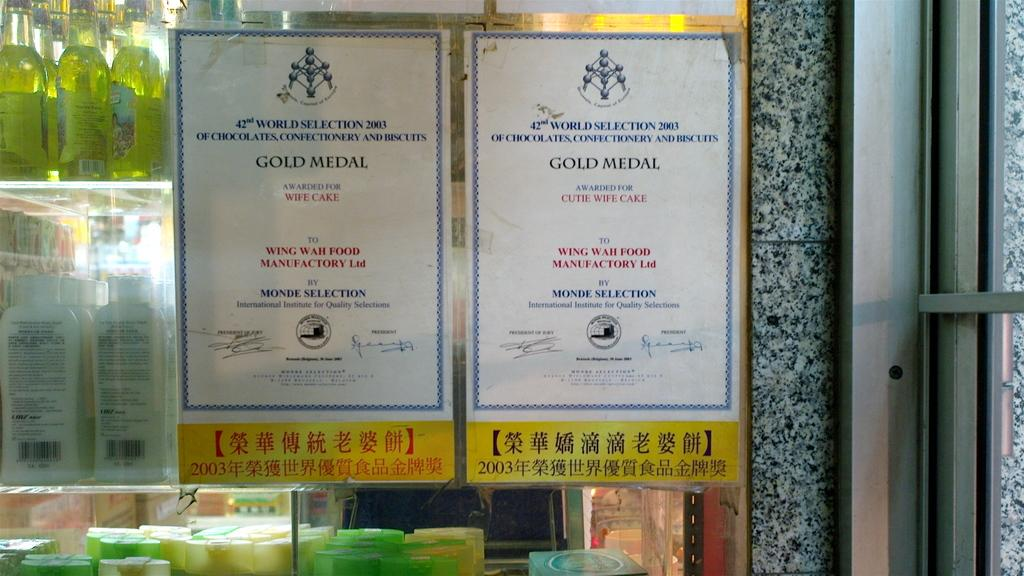<image>
Provide a brief description of the given image. Sign hanging outdoors of a window saying "Gold Medal". 